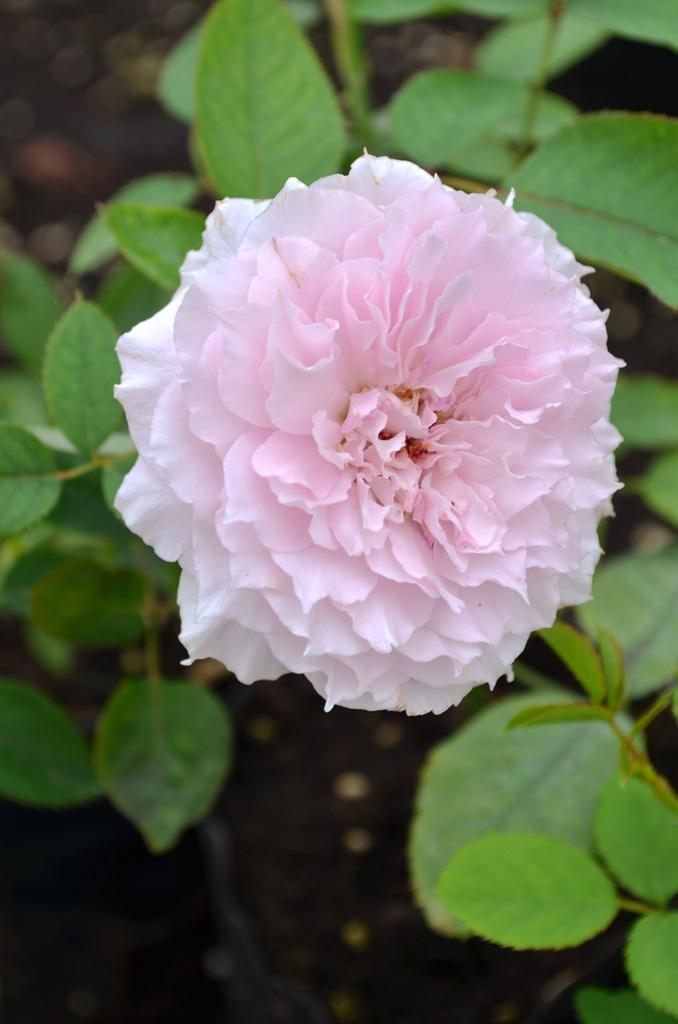What is the main subject of the image? There is a flower in the image. Can you describe the colors of the flower? The flower has white and pink colors. What else can be seen in the background of the image? There are green leaves in the background of the image. What type of clam can be seen in the image? There is no clam present in the image; it features a flower with white and pink colors and green leaves in the background. Is there a hospital or visitor mentioned in the image? No, the image does not contain any references to a hospital or visitor. 